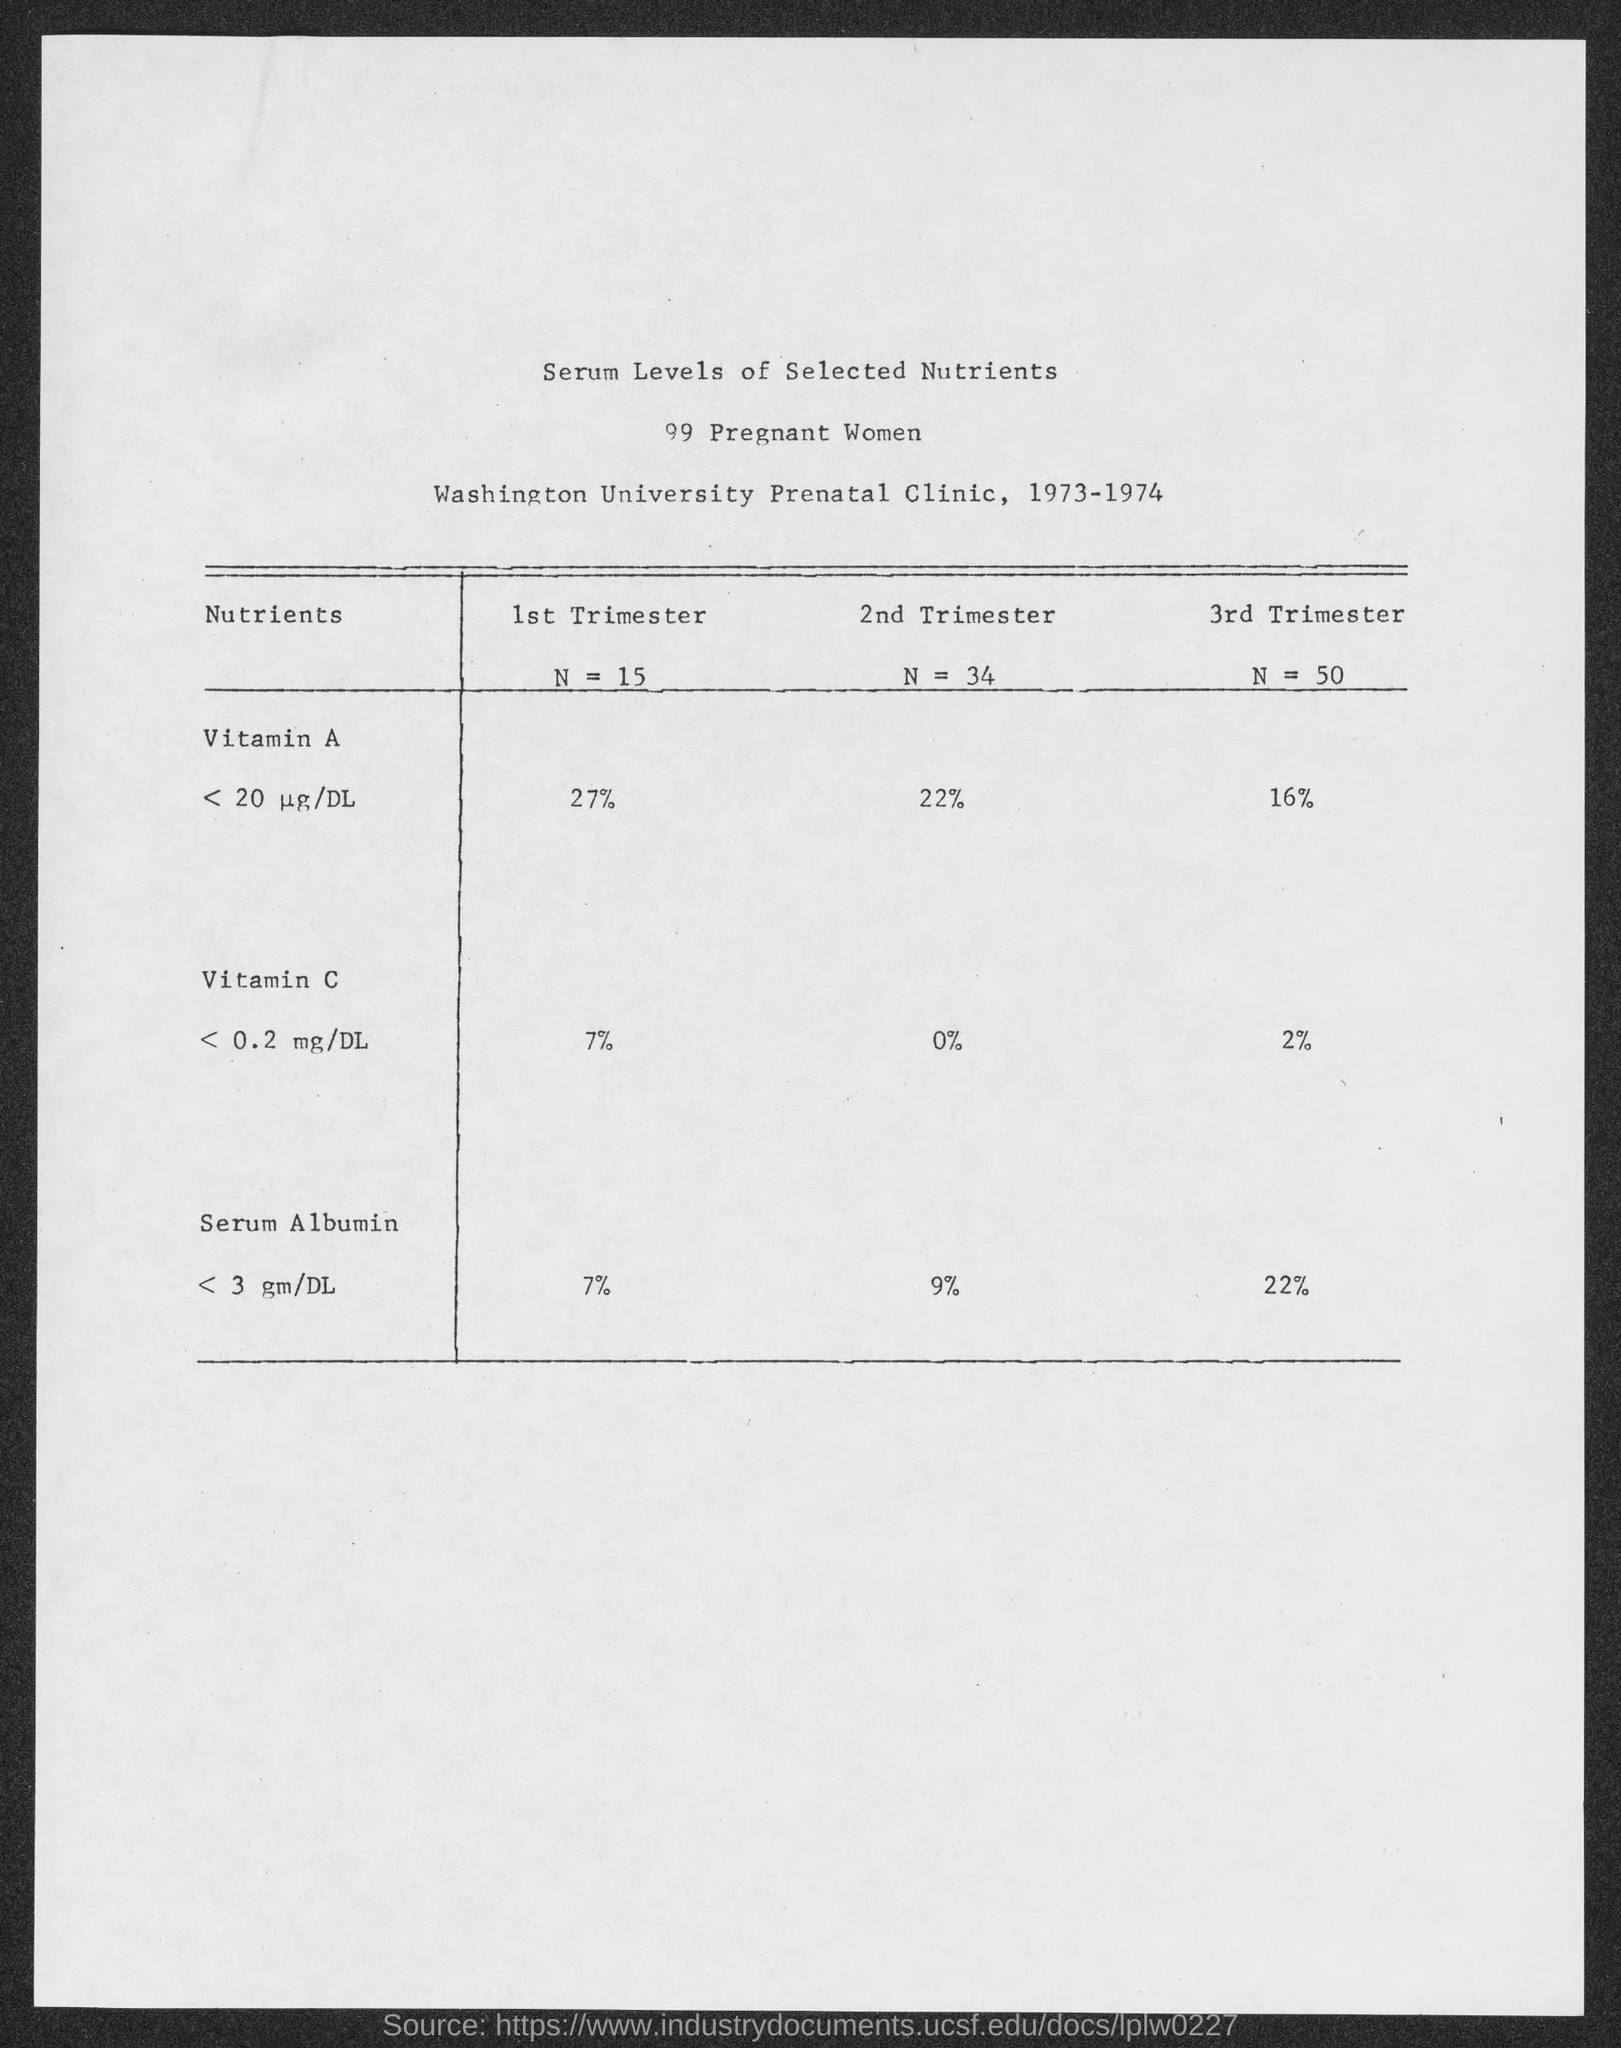List a handful of essential elements in this visual. In the first trimester, the value of N (a variable) is 15. The serum albumin level in the third trimester is 22%. The document mentions a range of years, specifically 1973 and 1974. The number of pregnant women is 99. According to the given information, in the second trimester, there is a value of 22% for Vitamin A. 